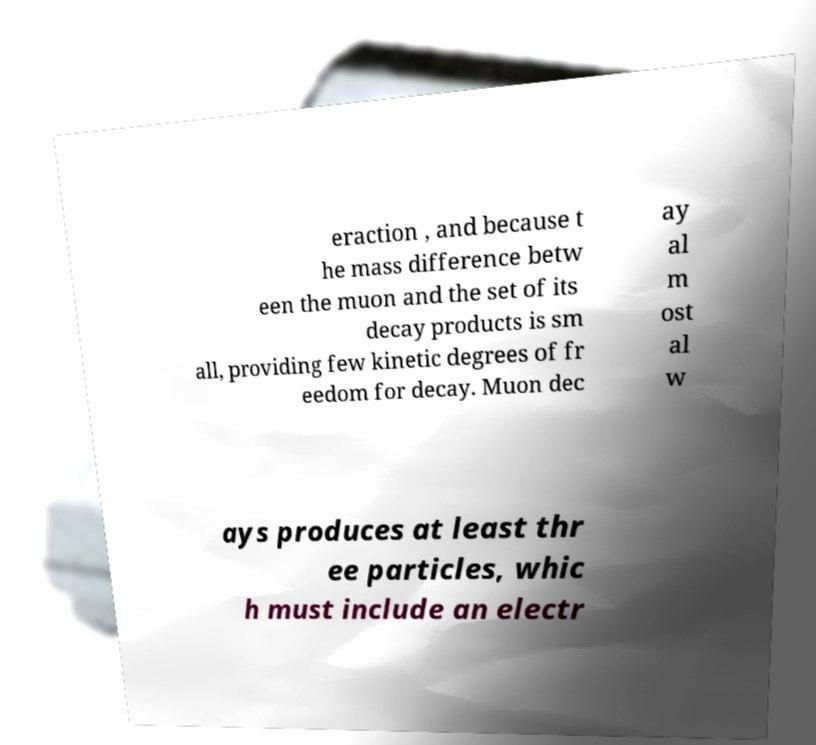Could you extract and type out the text from this image? eraction , and because t he mass difference betw een the muon and the set of its decay products is sm all, providing few kinetic degrees of fr eedom for decay. Muon dec ay al m ost al w ays produces at least thr ee particles, whic h must include an electr 